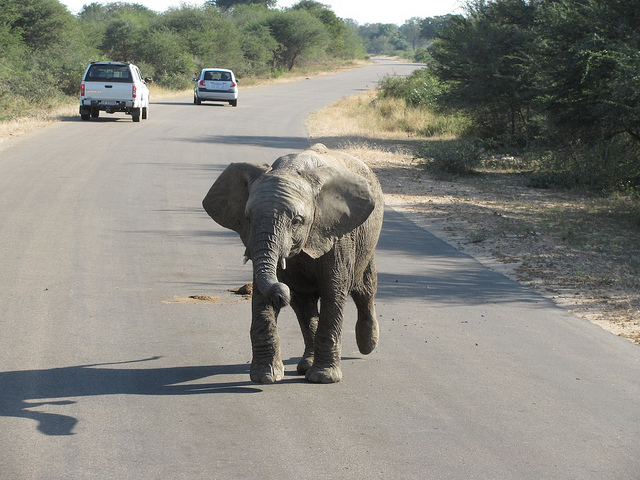How many cars are there? There are two cars visible in the image, both appear to be on the same side of the road, moving away from the viewpoint. 